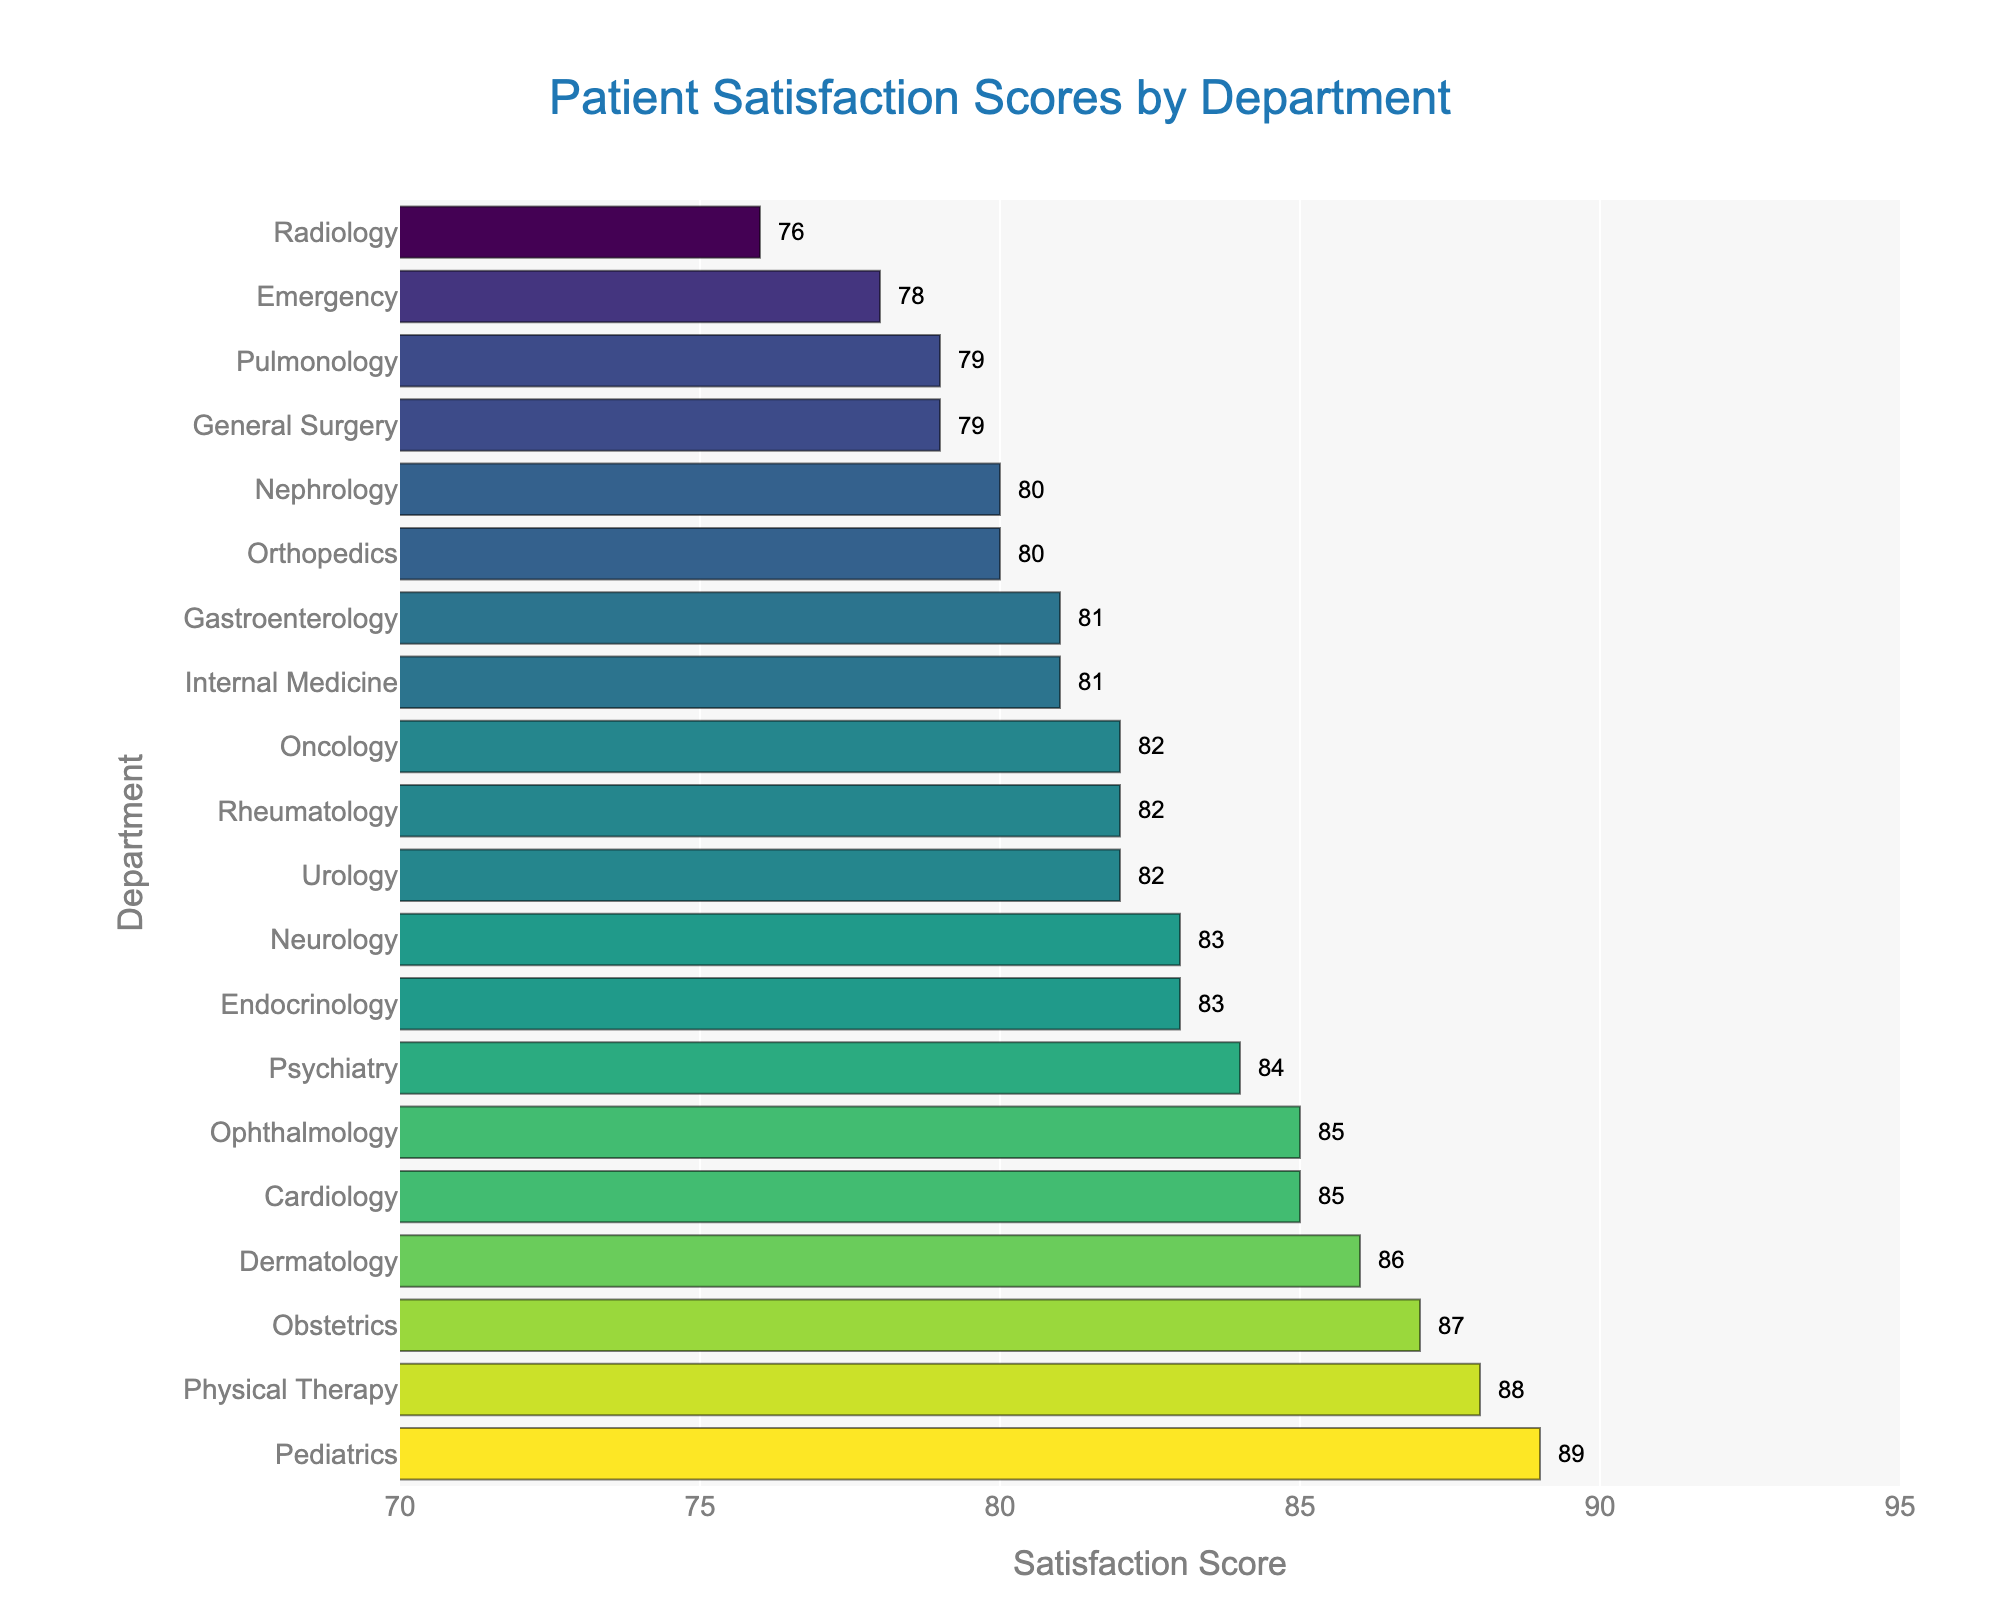Which department has the highest patient satisfaction score? The highest bar in the chart, signifying the department with the greatest satisfaction score, is Pediatrics at 89.
Answer: Pediatrics Which department has the lowest patient satisfaction score, and what is it? The shortest bar in the chart, representing the lowest satisfaction score, is Radiology at 76.
Answer: Radiology, 76 What is the difference in satisfaction scores between the Emergency and Obstetrics departments? The Emergency department has a score of 78, while Obstetrics has a score of 87. The difference is 87 - 78.
Answer: 9 What is the average satisfaction score of the top three departments? The top three departments by satisfaction scores are Pediatrics (89), Physical Therapy (88), and Obstetrics (87). The average is (89 + 88 + 87) / 3.
Answer: 88 Which departments have a satisfaction score of 82? Departments with scores of 82 are identified by finding the bars at the 82 mark: Oncology, Urology, and Rheumatology.
Answer: Oncology, Urology, Rheumatology Is the satisfaction score for Cardiology higher than that for Neurology? By comparing the lengths of the bars for these two departments, Cardiology (85) has a higher score than Neurology (83).
Answer: Yes What is the total satisfaction score for Cardiology, Psychiatry, and Dermatology? Summing the individual scores for these departments: Cardiology (85), Psychiatry (84), and Dermatology (86), results in 85 + 84 + 86.
Answer: 255 How many departments have a satisfaction score greater than 85? By counting the departments with bars exceeding the 85 mark, we have Pediatrics (89), Physical Therapy (88), Obstetrics (87), and Dermatology (86).
Answer: 4 What is the median satisfaction score across all departments? Sorting and finding the middle value among the 20 departments, the scores around the median rank are both 82, making the median value the average of these scores (82 and 82).
Answer: 82 